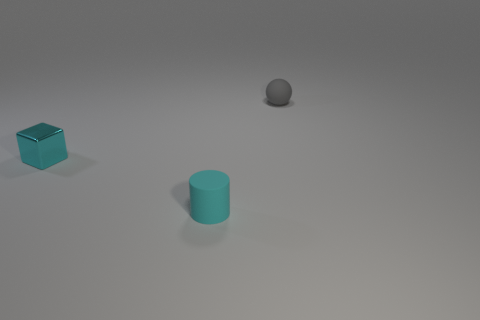Add 3 gray things. How many objects exist? 6 Subtract all balls. How many objects are left? 2 Subtract all big purple shiny objects. Subtract all gray rubber objects. How many objects are left? 2 Add 3 small gray matte things. How many small gray matte things are left? 4 Add 2 cubes. How many cubes exist? 3 Subtract 1 gray spheres. How many objects are left? 2 